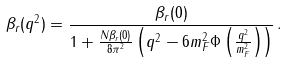Convert formula to latex. <formula><loc_0><loc_0><loc_500><loc_500>\beta _ { r } ( q ^ { 2 } ) = \frac { \beta _ { r } ( 0 ) } { 1 + \frac { N \beta _ { r } ( 0 ) } { 8 \pi ^ { 2 } } \left ( q ^ { 2 } - 6 m _ { F } ^ { 2 } \Phi \left ( \frac { q ^ { 2 } } { m _ { F } ^ { 2 } } \right ) \right ) } \, .</formula> 